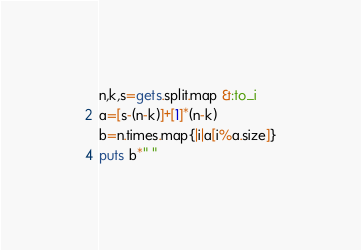<code> <loc_0><loc_0><loc_500><loc_500><_Ruby_>n,k,s=gets.split.map &:to_i
a=[s-(n-k)]+[1]*(n-k)
b=n.times.map{|i|a[i%a.size]}
puts b*" "</code> 